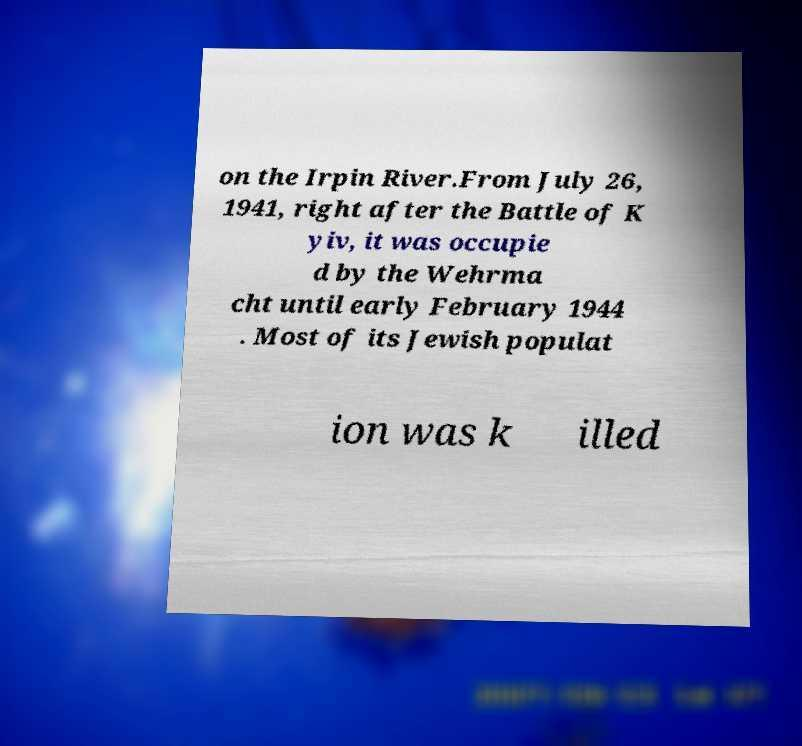For documentation purposes, I need the text within this image transcribed. Could you provide that? on the Irpin River.From July 26, 1941, right after the Battle of K yiv, it was occupie d by the Wehrma cht until early February 1944 . Most of its Jewish populat ion was k illed 